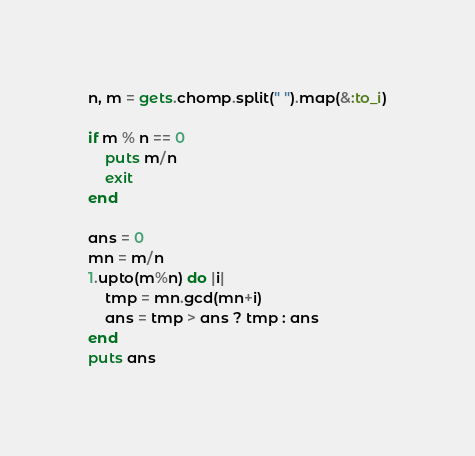Convert code to text. <code><loc_0><loc_0><loc_500><loc_500><_Ruby_>n, m = gets.chomp.split(" ").map(&:to_i)

if m % n == 0
    puts m/n
    exit
end

ans = 0
mn = m/n
1.upto(m%n) do |i|
    tmp = mn.gcd(mn+i)
    ans = tmp > ans ? tmp : ans
end
puts ans</code> 